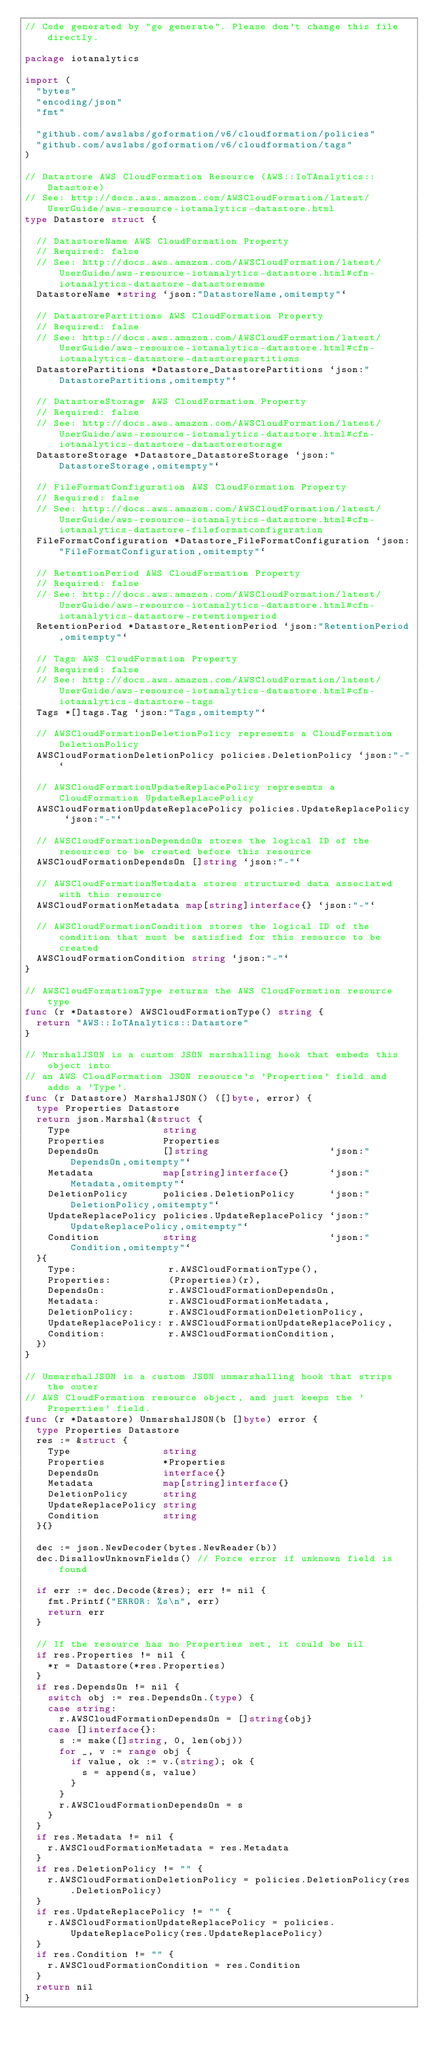<code> <loc_0><loc_0><loc_500><loc_500><_Go_>// Code generated by "go generate". Please don't change this file directly.

package iotanalytics

import (
	"bytes"
	"encoding/json"
	"fmt"

	"github.com/awslabs/goformation/v6/cloudformation/policies"
	"github.com/awslabs/goformation/v6/cloudformation/tags"
)

// Datastore AWS CloudFormation Resource (AWS::IoTAnalytics::Datastore)
// See: http://docs.aws.amazon.com/AWSCloudFormation/latest/UserGuide/aws-resource-iotanalytics-datastore.html
type Datastore struct {

	// DatastoreName AWS CloudFormation Property
	// Required: false
	// See: http://docs.aws.amazon.com/AWSCloudFormation/latest/UserGuide/aws-resource-iotanalytics-datastore.html#cfn-iotanalytics-datastore-datastorename
	DatastoreName *string `json:"DatastoreName,omitempty"`

	// DatastorePartitions AWS CloudFormation Property
	// Required: false
	// See: http://docs.aws.amazon.com/AWSCloudFormation/latest/UserGuide/aws-resource-iotanalytics-datastore.html#cfn-iotanalytics-datastore-datastorepartitions
	DatastorePartitions *Datastore_DatastorePartitions `json:"DatastorePartitions,omitempty"`

	// DatastoreStorage AWS CloudFormation Property
	// Required: false
	// See: http://docs.aws.amazon.com/AWSCloudFormation/latest/UserGuide/aws-resource-iotanalytics-datastore.html#cfn-iotanalytics-datastore-datastorestorage
	DatastoreStorage *Datastore_DatastoreStorage `json:"DatastoreStorage,omitempty"`

	// FileFormatConfiguration AWS CloudFormation Property
	// Required: false
	// See: http://docs.aws.amazon.com/AWSCloudFormation/latest/UserGuide/aws-resource-iotanalytics-datastore.html#cfn-iotanalytics-datastore-fileformatconfiguration
	FileFormatConfiguration *Datastore_FileFormatConfiguration `json:"FileFormatConfiguration,omitempty"`

	// RetentionPeriod AWS CloudFormation Property
	// Required: false
	// See: http://docs.aws.amazon.com/AWSCloudFormation/latest/UserGuide/aws-resource-iotanalytics-datastore.html#cfn-iotanalytics-datastore-retentionperiod
	RetentionPeriod *Datastore_RetentionPeriod `json:"RetentionPeriod,omitempty"`

	// Tags AWS CloudFormation Property
	// Required: false
	// See: http://docs.aws.amazon.com/AWSCloudFormation/latest/UserGuide/aws-resource-iotanalytics-datastore.html#cfn-iotanalytics-datastore-tags
	Tags *[]tags.Tag `json:"Tags,omitempty"`

	// AWSCloudFormationDeletionPolicy represents a CloudFormation DeletionPolicy
	AWSCloudFormationDeletionPolicy policies.DeletionPolicy `json:"-"`

	// AWSCloudFormationUpdateReplacePolicy represents a CloudFormation UpdateReplacePolicy
	AWSCloudFormationUpdateReplacePolicy policies.UpdateReplacePolicy `json:"-"`

	// AWSCloudFormationDependsOn stores the logical ID of the resources to be created before this resource
	AWSCloudFormationDependsOn []string `json:"-"`

	// AWSCloudFormationMetadata stores structured data associated with this resource
	AWSCloudFormationMetadata map[string]interface{} `json:"-"`

	// AWSCloudFormationCondition stores the logical ID of the condition that must be satisfied for this resource to be created
	AWSCloudFormationCondition string `json:"-"`
}

// AWSCloudFormationType returns the AWS CloudFormation resource type
func (r *Datastore) AWSCloudFormationType() string {
	return "AWS::IoTAnalytics::Datastore"
}

// MarshalJSON is a custom JSON marshalling hook that embeds this object into
// an AWS CloudFormation JSON resource's 'Properties' field and adds a 'Type'.
func (r Datastore) MarshalJSON() ([]byte, error) {
	type Properties Datastore
	return json.Marshal(&struct {
		Type                string
		Properties          Properties
		DependsOn           []string                     `json:"DependsOn,omitempty"`
		Metadata            map[string]interface{}       `json:"Metadata,omitempty"`
		DeletionPolicy      policies.DeletionPolicy      `json:"DeletionPolicy,omitempty"`
		UpdateReplacePolicy policies.UpdateReplacePolicy `json:"UpdateReplacePolicy,omitempty"`
		Condition           string                       `json:"Condition,omitempty"`
	}{
		Type:                r.AWSCloudFormationType(),
		Properties:          (Properties)(r),
		DependsOn:           r.AWSCloudFormationDependsOn,
		Metadata:            r.AWSCloudFormationMetadata,
		DeletionPolicy:      r.AWSCloudFormationDeletionPolicy,
		UpdateReplacePolicy: r.AWSCloudFormationUpdateReplacePolicy,
		Condition:           r.AWSCloudFormationCondition,
	})
}

// UnmarshalJSON is a custom JSON unmarshalling hook that strips the outer
// AWS CloudFormation resource object, and just keeps the 'Properties' field.
func (r *Datastore) UnmarshalJSON(b []byte) error {
	type Properties Datastore
	res := &struct {
		Type                string
		Properties          *Properties
		DependsOn           interface{}
		Metadata            map[string]interface{}
		DeletionPolicy      string
		UpdateReplacePolicy string
		Condition           string
	}{}

	dec := json.NewDecoder(bytes.NewReader(b))
	dec.DisallowUnknownFields() // Force error if unknown field is found

	if err := dec.Decode(&res); err != nil {
		fmt.Printf("ERROR: %s\n", err)
		return err
	}

	// If the resource has no Properties set, it could be nil
	if res.Properties != nil {
		*r = Datastore(*res.Properties)
	}
	if res.DependsOn != nil {
		switch obj := res.DependsOn.(type) {
		case string:
			r.AWSCloudFormationDependsOn = []string{obj}
		case []interface{}:
			s := make([]string, 0, len(obj))
			for _, v := range obj {
				if value, ok := v.(string); ok {
					s = append(s, value)
				}
			}
			r.AWSCloudFormationDependsOn = s
		}
	}
	if res.Metadata != nil {
		r.AWSCloudFormationMetadata = res.Metadata
	}
	if res.DeletionPolicy != "" {
		r.AWSCloudFormationDeletionPolicy = policies.DeletionPolicy(res.DeletionPolicy)
	}
	if res.UpdateReplacePolicy != "" {
		r.AWSCloudFormationUpdateReplacePolicy = policies.UpdateReplacePolicy(res.UpdateReplacePolicy)
	}
	if res.Condition != "" {
		r.AWSCloudFormationCondition = res.Condition
	}
	return nil
}
</code> 